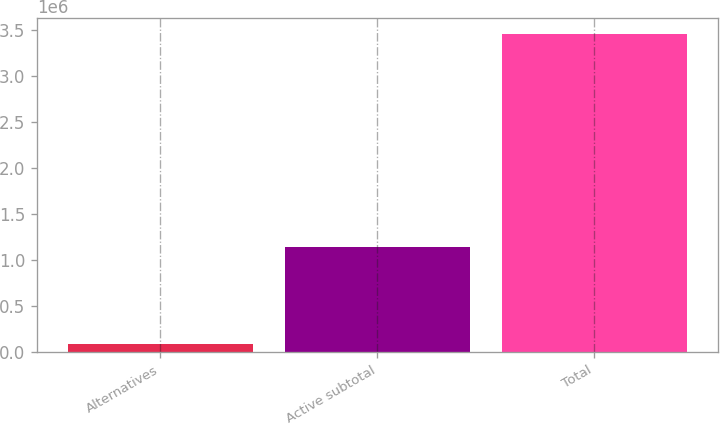<chart> <loc_0><loc_0><loc_500><loc_500><bar_chart><fcel>Alternatives<fcel>Active subtotal<fcel>Total<nl><fcel>84248<fcel>1.13931e+06<fcel>3.45612e+06<nl></chart> 